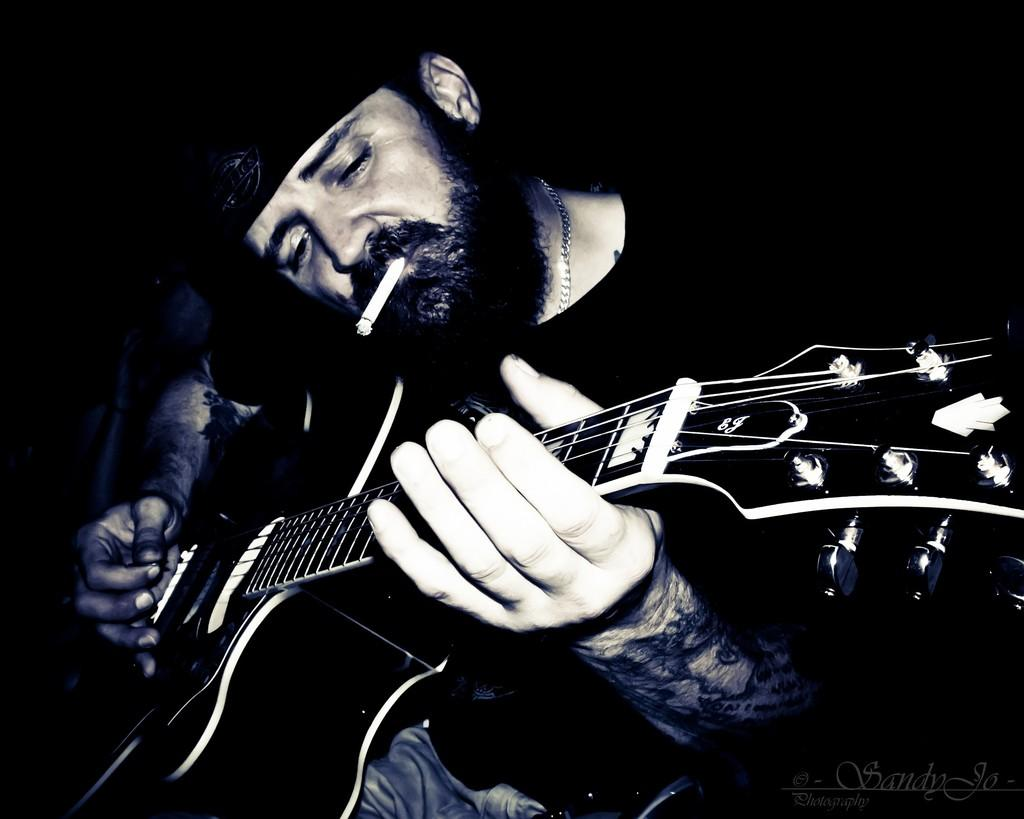What is the man in the image doing? The man is playing a guitar in the image. What object is the man holding in the image? The man is holding a guitar in the image. Can you describe the man's appearance in the image? The man has a cigarette in his mouth in the image. What type of insurance does the man offer in the image? There is no indication in the image that the man is offering any type of insurance. 